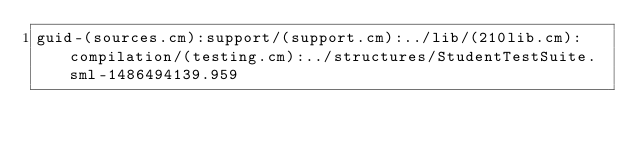Convert code to text. <code><loc_0><loc_0><loc_500><loc_500><_SML_>guid-(sources.cm):support/(support.cm):../lib/(210lib.cm):compilation/(testing.cm):../structures/StudentTestSuite.sml-1486494139.959
</code> 